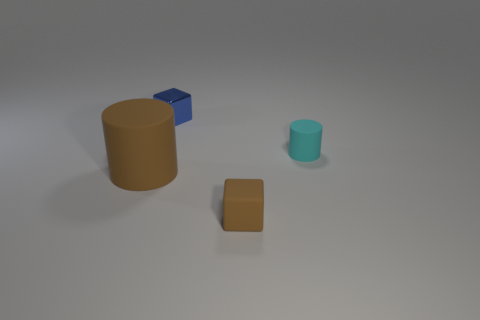Add 3 tiny brown things. How many objects exist? 7 Add 3 cubes. How many cubes exist? 5 Subtract 0 brown balls. How many objects are left? 4 Subtract all small yellow cylinders. Subtract all brown things. How many objects are left? 2 Add 1 brown rubber objects. How many brown rubber objects are left? 3 